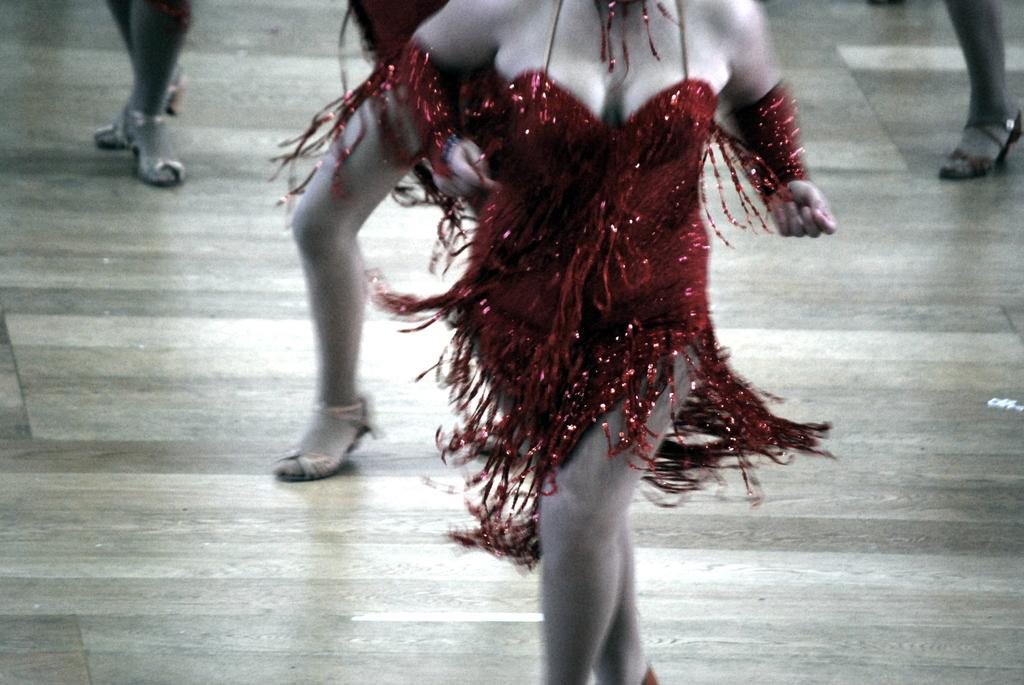What is happening in the image? There are people standing in the image. Can you describe the clothing of one of the people? One of the people is wearing a red dress. How many frogs are jumping in the image? There are no frogs present in the image, and therefore no jumping frogs can be observed. What type of building is visible in the image? There is no building visible in the image; it only shows people standing. 